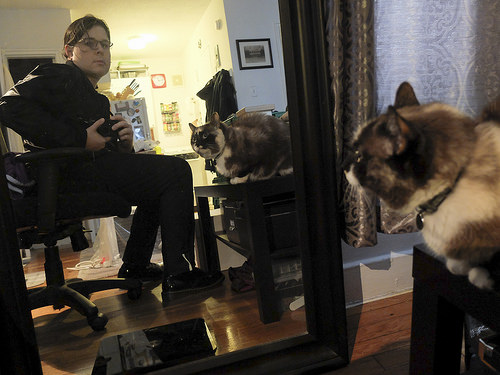<image>
Is there a cat on the table? Yes. Looking at the image, I can see the cat is positioned on top of the table, with the table providing support. 